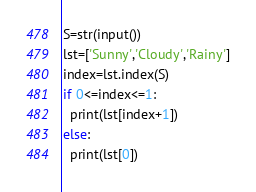<code> <loc_0><loc_0><loc_500><loc_500><_Python_>S=str(input())
lst=['Sunny','Cloudy','Rainy']
index=lst.index(S)
if 0<=index<=1:
  print(lst[index+1])
else:
  print(lst[0])</code> 